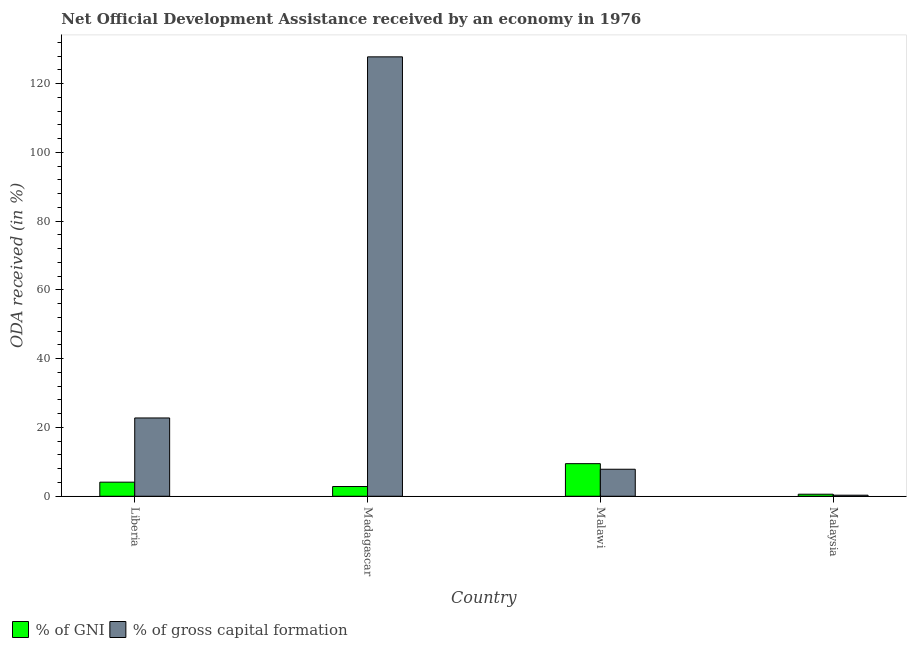How many different coloured bars are there?
Provide a short and direct response. 2. Are the number of bars per tick equal to the number of legend labels?
Your answer should be compact. Yes. Are the number of bars on each tick of the X-axis equal?
Make the answer very short. Yes. How many bars are there on the 3rd tick from the left?
Your answer should be very brief. 2. How many bars are there on the 4th tick from the right?
Offer a terse response. 2. What is the label of the 2nd group of bars from the left?
Provide a succinct answer. Madagascar. In how many cases, is the number of bars for a given country not equal to the number of legend labels?
Give a very brief answer. 0. What is the oda received as percentage of gross capital formation in Malaysia?
Your response must be concise. 0.31. Across all countries, what is the maximum oda received as percentage of gni?
Make the answer very short. 9.48. Across all countries, what is the minimum oda received as percentage of gross capital formation?
Offer a terse response. 0.31. In which country was the oda received as percentage of gni maximum?
Your response must be concise. Malawi. In which country was the oda received as percentage of gni minimum?
Provide a succinct answer. Malaysia. What is the total oda received as percentage of gross capital formation in the graph?
Offer a very short reply. 158.7. What is the difference between the oda received as percentage of gross capital formation in Madagascar and that in Malawi?
Your response must be concise. 119.92. What is the difference between the oda received as percentage of gross capital formation in Madagascar and the oda received as percentage of gni in Liberia?
Your answer should be very brief. 123.67. What is the average oda received as percentage of gni per country?
Provide a short and direct response. 4.25. What is the difference between the oda received as percentage of gross capital formation and oda received as percentage of gni in Madagascar?
Give a very brief answer. 124.94. In how many countries, is the oda received as percentage of gni greater than 36 %?
Give a very brief answer. 0. What is the ratio of the oda received as percentage of gni in Madagascar to that in Malaysia?
Offer a terse response. 4.77. Is the oda received as percentage of gni in Liberia less than that in Madagascar?
Offer a very short reply. No. Is the difference between the oda received as percentage of gni in Madagascar and Malawi greater than the difference between the oda received as percentage of gross capital formation in Madagascar and Malawi?
Your answer should be compact. No. What is the difference between the highest and the second highest oda received as percentage of gross capital formation?
Keep it short and to the point. 105.01. What is the difference between the highest and the lowest oda received as percentage of gross capital formation?
Your answer should be very brief. 127.46. In how many countries, is the oda received as percentage of gni greater than the average oda received as percentage of gni taken over all countries?
Your answer should be compact. 1. What does the 1st bar from the left in Madagascar represents?
Keep it short and to the point. % of GNI. What does the 1st bar from the right in Malaysia represents?
Your response must be concise. % of gross capital formation. How many bars are there?
Provide a succinct answer. 8. Are all the bars in the graph horizontal?
Provide a short and direct response. No. How many countries are there in the graph?
Your answer should be compact. 4. What is the difference between two consecutive major ticks on the Y-axis?
Your answer should be very brief. 20. How are the legend labels stacked?
Keep it short and to the point. Horizontal. What is the title of the graph?
Your response must be concise. Net Official Development Assistance received by an economy in 1976. What is the label or title of the X-axis?
Your answer should be compact. Country. What is the label or title of the Y-axis?
Your response must be concise. ODA received (in %). What is the ODA received (in %) in % of GNI in Liberia?
Keep it short and to the point. 4.1. What is the ODA received (in %) of % of gross capital formation in Liberia?
Keep it short and to the point. 22.76. What is the ODA received (in %) of % of GNI in Madagascar?
Your answer should be compact. 2.83. What is the ODA received (in %) in % of gross capital formation in Madagascar?
Your response must be concise. 127.77. What is the ODA received (in %) of % of GNI in Malawi?
Provide a succinct answer. 9.48. What is the ODA received (in %) of % of gross capital formation in Malawi?
Give a very brief answer. 7.85. What is the ODA received (in %) of % of GNI in Malaysia?
Your answer should be compact. 0.59. What is the ODA received (in %) in % of gross capital formation in Malaysia?
Keep it short and to the point. 0.31. Across all countries, what is the maximum ODA received (in %) in % of GNI?
Ensure brevity in your answer.  9.48. Across all countries, what is the maximum ODA received (in %) of % of gross capital formation?
Your response must be concise. 127.77. Across all countries, what is the minimum ODA received (in %) in % of GNI?
Make the answer very short. 0.59. Across all countries, what is the minimum ODA received (in %) in % of gross capital formation?
Ensure brevity in your answer.  0.31. What is the total ODA received (in %) in % of GNI in the graph?
Make the answer very short. 16.99. What is the total ODA received (in %) in % of gross capital formation in the graph?
Your response must be concise. 158.7. What is the difference between the ODA received (in %) in % of GNI in Liberia and that in Madagascar?
Provide a succinct answer. 1.27. What is the difference between the ODA received (in %) in % of gross capital formation in Liberia and that in Madagascar?
Your answer should be compact. -105. What is the difference between the ODA received (in %) in % of GNI in Liberia and that in Malawi?
Your answer should be compact. -5.38. What is the difference between the ODA received (in %) in % of gross capital formation in Liberia and that in Malawi?
Keep it short and to the point. 14.91. What is the difference between the ODA received (in %) of % of GNI in Liberia and that in Malaysia?
Your response must be concise. 3.5. What is the difference between the ODA received (in %) in % of gross capital formation in Liberia and that in Malaysia?
Keep it short and to the point. 22.46. What is the difference between the ODA received (in %) of % of GNI in Madagascar and that in Malawi?
Your answer should be very brief. -6.65. What is the difference between the ODA received (in %) of % of gross capital formation in Madagascar and that in Malawi?
Make the answer very short. 119.92. What is the difference between the ODA received (in %) in % of GNI in Madagascar and that in Malaysia?
Make the answer very short. 2.24. What is the difference between the ODA received (in %) in % of gross capital formation in Madagascar and that in Malaysia?
Your answer should be very brief. 127.46. What is the difference between the ODA received (in %) of % of GNI in Malawi and that in Malaysia?
Give a very brief answer. 8.88. What is the difference between the ODA received (in %) in % of gross capital formation in Malawi and that in Malaysia?
Offer a terse response. 7.54. What is the difference between the ODA received (in %) in % of GNI in Liberia and the ODA received (in %) in % of gross capital formation in Madagascar?
Offer a very short reply. -123.67. What is the difference between the ODA received (in %) of % of GNI in Liberia and the ODA received (in %) of % of gross capital formation in Malawi?
Keep it short and to the point. -3.76. What is the difference between the ODA received (in %) in % of GNI in Liberia and the ODA received (in %) in % of gross capital formation in Malaysia?
Provide a short and direct response. 3.79. What is the difference between the ODA received (in %) of % of GNI in Madagascar and the ODA received (in %) of % of gross capital formation in Malawi?
Your answer should be very brief. -5.03. What is the difference between the ODA received (in %) of % of GNI in Madagascar and the ODA received (in %) of % of gross capital formation in Malaysia?
Offer a terse response. 2.52. What is the difference between the ODA received (in %) of % of GNI in Malawi and the ODA received (in %) of % of gross capital formation in Malaysia?
Make the answer very short. 9.17. What is the average ODA received (in %) in % of GNI per country?
Your answer should be very brief. 4.25. What is the average ODA received (in %) in % of gross capital formation per country?
Ensure brevity in your answer.  39.67. What is the difference between the ODA received (in %) in % of GNI and ODA received (in %) in % of gross capital formation in Liberia?
Make the answer very short. -18.67. What is the difference between the ODA received (in %) in % of GNI and ODA received (in %) in % of gross capital formation in Madagascar?
Provide a succinct answer. -124.94. What is the difference between the ODA received (in %) of % of GNI and ODA received (in %) of % of gross capital formation in Malawi?
Your answer should be compact. 1.62. What is the difference between the ODA received (in %) in % of GNI and ODA received (in %) in % of gross capital formation in Malaysia?
Offer a terse response. 0.28. What is the ratio of the ODA received (in %) of % of GNI in Liberia to that in Madagascar?
Offer a terse response. 1.45. What is the ratio of the ODA received (in %) of % of gross capital formation in Liberia to that in Madagascar?
Your answer should be very brief. 0.18. What is the ratio of the ODA received (in %) of % of GNI in Liberia to that in Malawi?
Make the answer very short. 0.43. What is the ratio of the ODA received (in %) in % of gross capital formation in Liberia to that in Malawi?
Ensure brevity in your answer.  2.9. What is the ratio of the ODA received (in %) in % of GNI in Liberia to that in Malaysia?
Ensure brevity in your answer.  6.92. What is the ratio of the ODA received (in %) in % of gross capital formation in Liberia to that in Malaysia?
Ensure brevity in your answer.  73.81. What is the ratio of the ODA received (in %) of % of GNI in Madagascar to that in Malawi?
Provide a succinct answer. 0.3. What is the ratio of the ODA received (in %) of % of gross capital formation in Madagascar to that in Malawi?
Provide a short and direct response. 16.27. What is the ratio of the ODA received (in %) in % of GNI in Madagascar to that in Malaysia?
Make the answer very short. 4.77. What is the ratio of the ODA received (in %) in % of gross capital formation in Madagascar to that in Malaysia?
Keep it short and to the point. 414.26. What is the ratio of the ODA received (in %) of % of GNI in Malawi to that in Malaysia?
Your answer should be compact. 16. What is the ratio of the ODA received (in %) of % of gross capital formation in Malawi to that in Malaysia?
Offer a terse response. 25.46. What is the difference between the highest and the second highest ODA received (in %) of % of GNI?
Ensure brevity in your answer.  5.38. What is the difference between the highest and the second highest ODA received (in %) of % of gross capital formation?
Keep it short and to the point. 105. What is the difference between the highest and the lowest ODA received (in %) of % of GNI?
Your response must be concise. 8.88. What is the difference between the highest and the lowest ODA received (in %) of % of gross capital formation?
Offer a very short reply. 127.46. 